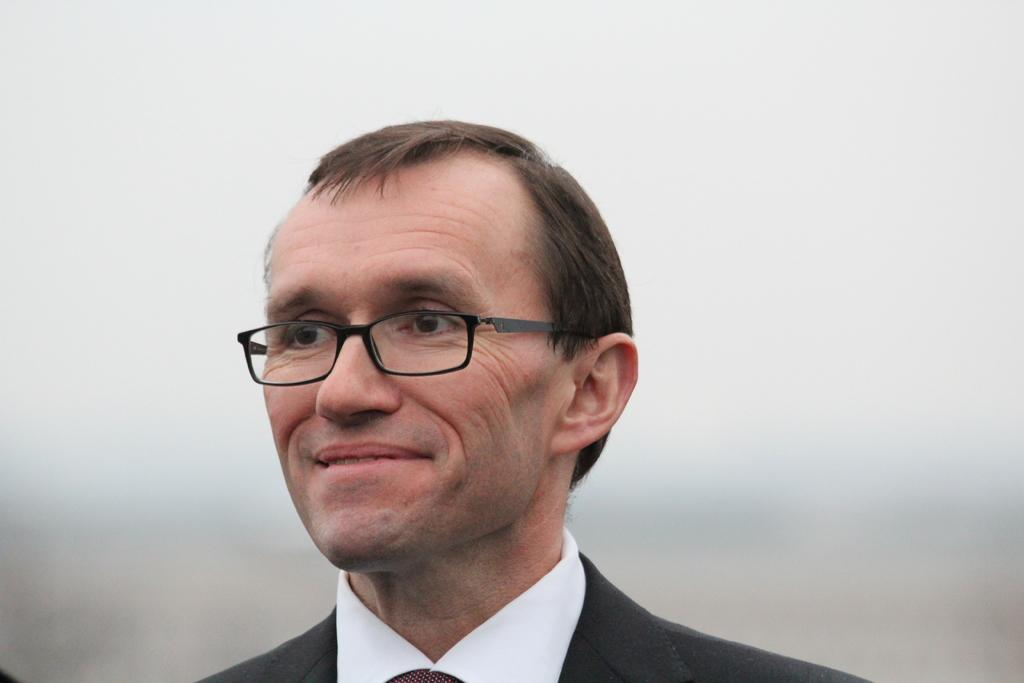Who is present in the image? There is a man in the image. What is the man doing in the image? The man is smiling in the image. What accessory is the man wearing? The man is wearing glasses (specs) in the image. Can you describe the background of the image? The background of the image is blurry. What type of lamp is on the man's head in the image? There is no lamp present on the man's head in the image. 